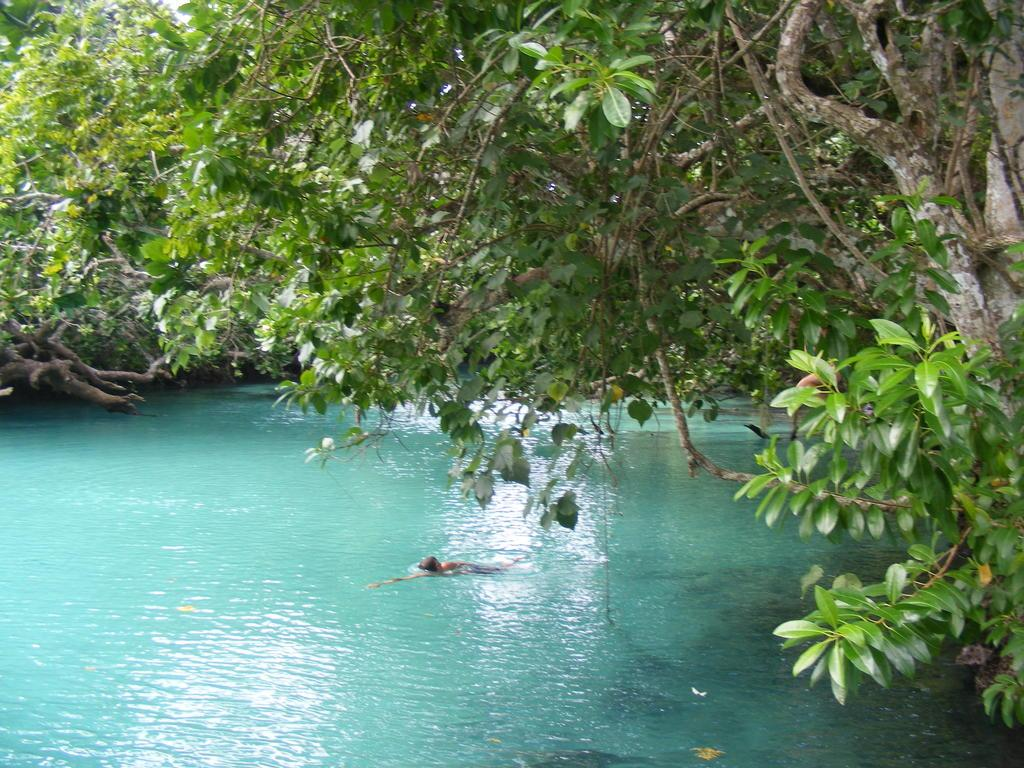What is the person in the image doing? The person is swimming in the water. What can be seen in the background of the image? There are trees visible in the background of the image. What type of line can be seen connecting the trees in the image? There is no line connecting the trees in the image. What industry is depicted in the image? The image does not depict any industry; it features a person swimming and trees in the background. 